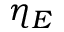Convert formula to latex. <formula><loc_0><loc_0><loc_500><loc_500>\eta _ { E }</formula> 